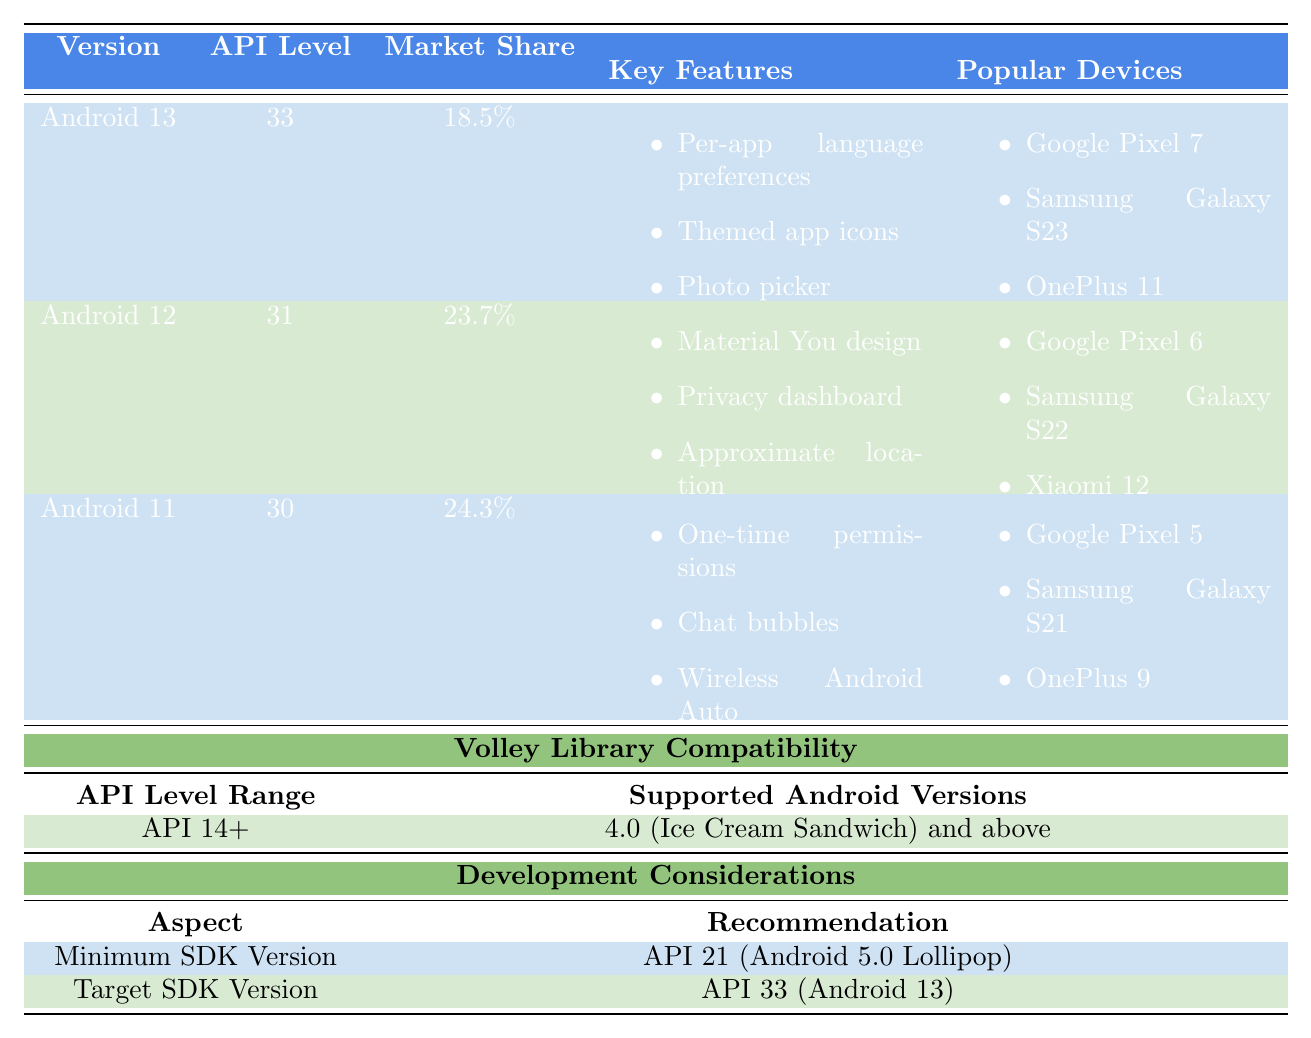What is the market share of Android 12? According to the table, the market share of Android 12 is displayed directly next to its version number, which shows 23.7%.
Answer: 23.7% Which has a higher market share: Android 11 or Android 10? The market share of Android 11 is 24.3%, while for Android 10 it is 15.8%. Since 24.3% is greater than 15.8%, Android 11 has the higher market share.
Answer: Android 11 How many key features does Android 9 Pie have? The table lists three key features for Android 9 Pie: Adaptive Battery, App Actions, and Slices.
Answer: 3 Is Android 8.0-8.1 supported by Volley Library? The table shows that the Volley Library starts at API Level 14, which encompasses Android 4.0 and above. Since Android 8.0-8.1 falls within this range, it is supported.
Answer: Yes What is the difference in market share between Android 11 and Android 12? Android 11 has a market share of 24.3% and Android 12 has a market share of 23.7%. The difference can be calculated as 24.3% - 23.7% = 0.6%.
Answer: 0.6% What are the key benefits of using the Volley Library? The table states the key benefits of the Volley Library are automatic scheduling of network requests, multiple concurrent network connections, and transparent disk and memory caching.
Answer: 3 benefits Which Android version has the lowest market share? The lowest market share in the table is for Android 7.0-7.1 Nougat, which has a market share of 1.7%.
Answer: Android 7.0-7.1 Nougat What is the recommended target SDK version? The table clearly states the recommended target SDK version is API 33 (Android 13).
Answer: API 33 Considering the recommended minimum SDK version, what percentage of active devices is covered? The table mentions that API 21 (Android 5.0 Lollipop) covers 99.2% of active Android devices.
Answer: 99.2% Which Android version introduced the Material You design? According to the table, the Material You design was introduced in Android 12, as listed under its key features.
Answer: Android 12 If you were to add Android 10's market share to Android 9 Pie's market share, what would be the total? Android 10 has a market share of 15.8% and Android 9 Pie has a market share of 10.2%. The total would be calculated as 15.8% + 10.2% = 26%.
Answer: 26% 